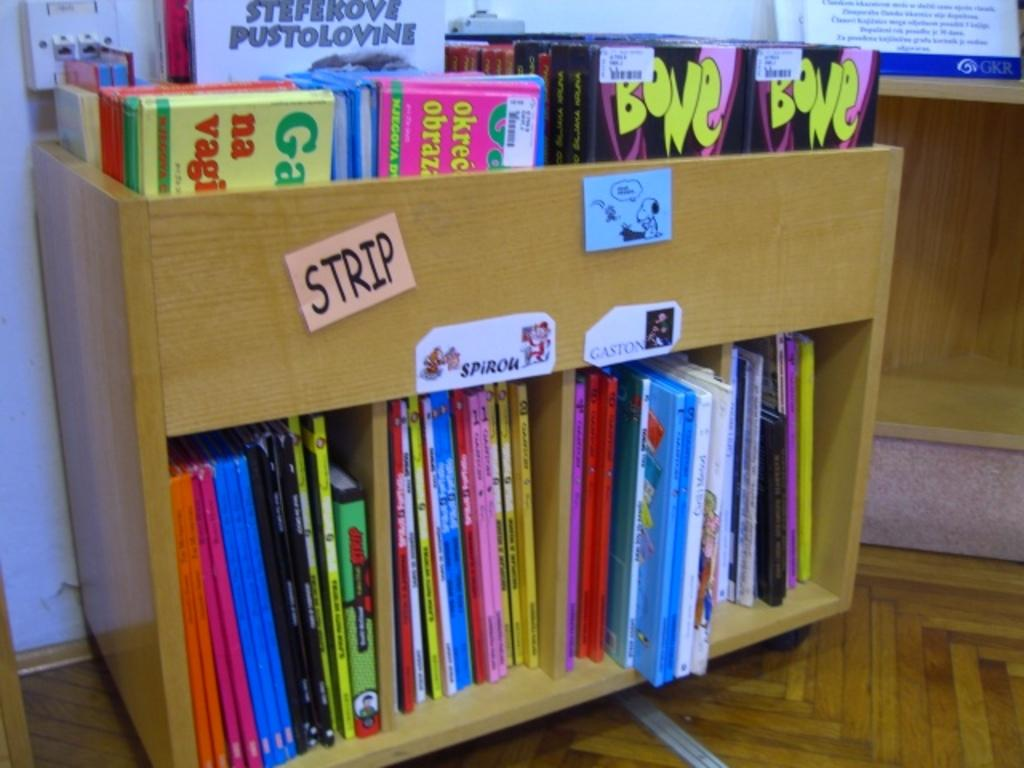<image>
Give a short and clear explanation of the subsequent image. A small bookcase of kids books has a post-it on it with the word Strip. 